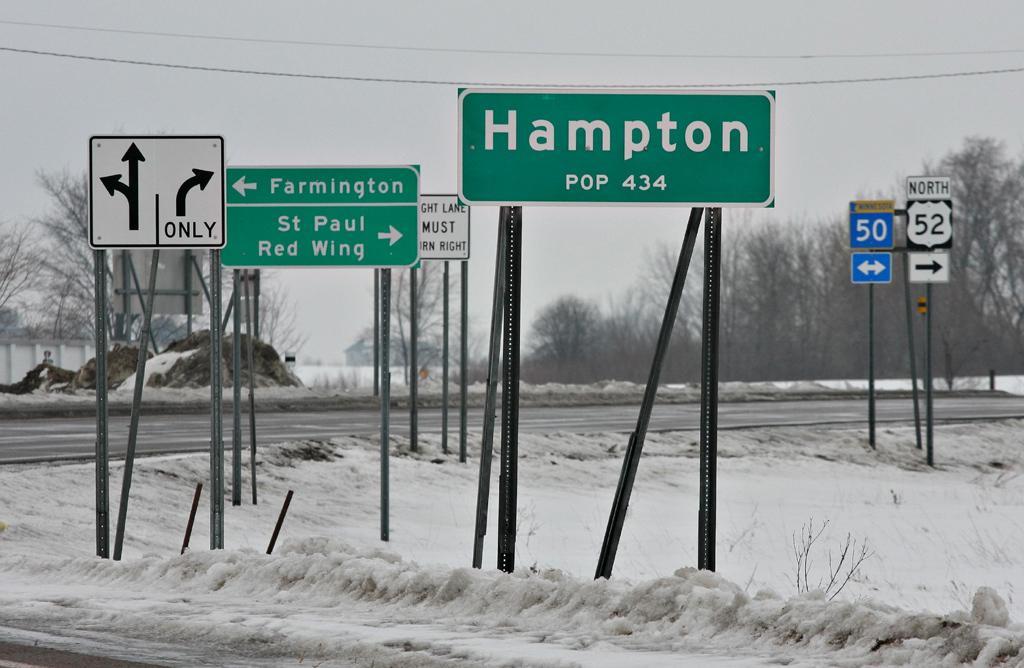Can you describe this image briefly? This picture shows few trees and couple of name boards and few sign boards to the poles and we see snow and a cloudy sky and we see a building. 